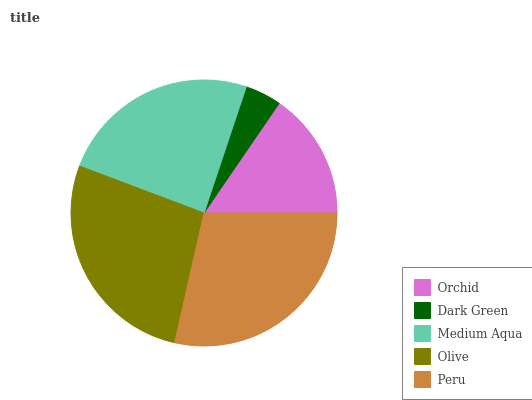Is Dark Green the minimum?
Answer yes or no. Yes. Is Peru the maximum?
Answer yes or no. Yes. Is Medium Aqua the minimum?
Answer yes or no. No. Is Medium Aqua the maximum?
Answer yes or no. No. Is Medium Aqua greater than Dark Green?
Answer yes or no. Yes. Is Dark Green less than Medium Aqua?
Answer yes or no. Yes. Is Dark Green greater than Medium Aqua?
Answer yes or no. No. Is Medium Aqua less than Dark Green?
Answer yes or no. No. Is Medium Aqua the high median?
Answer yes or no. Yes. Is Medium Aqua the low median?
Answer yes or no. Yes. Is Orchid the high median?
Answer yes or no. No. Is Dark Green the low median?
Answer yes or no. No. 